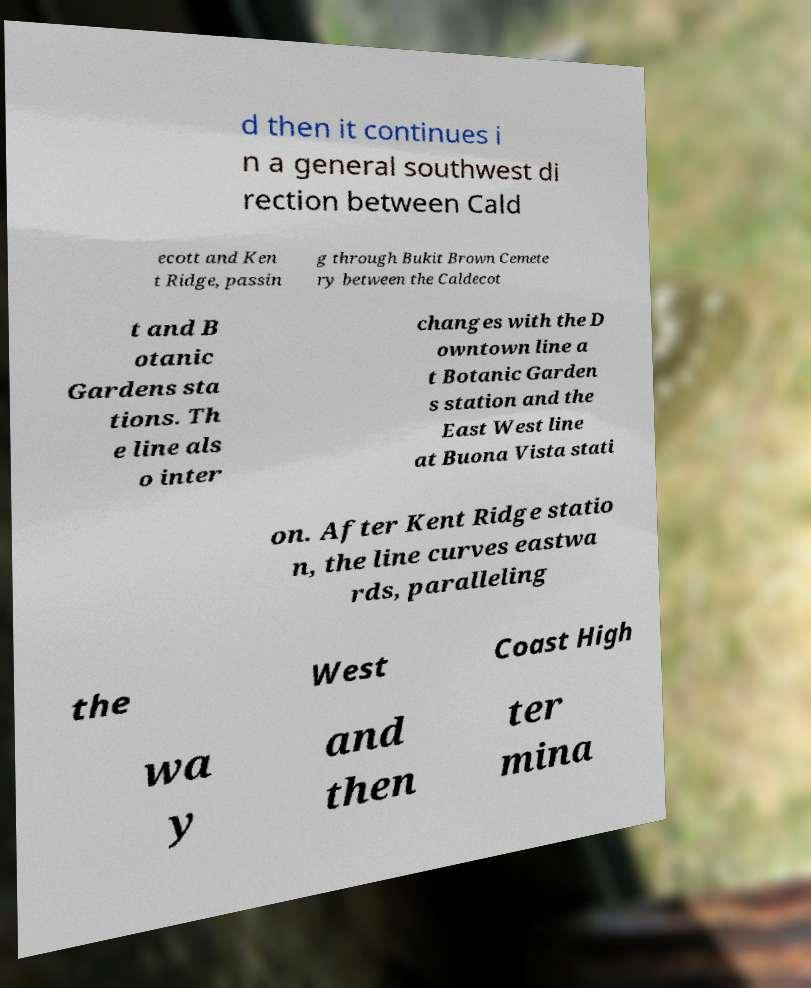There's text embedded in this image that I need extracted. Can you transcribe it verbatim? d then it continues i n a general southwest di rection between Cald ecott and Ken t Ridge, passin g through Bukit Brown Cemete ry between the Caldecot t and B otanic Gardens sta tions. Th e line als o inter changes with the D owntown line a t Botanic Garden s station and the East West line at Buona Vista stati on. After Kent Ridge statio n, the line curves eastwa rds, paralleling the West Coast High wa y and then ter mina 